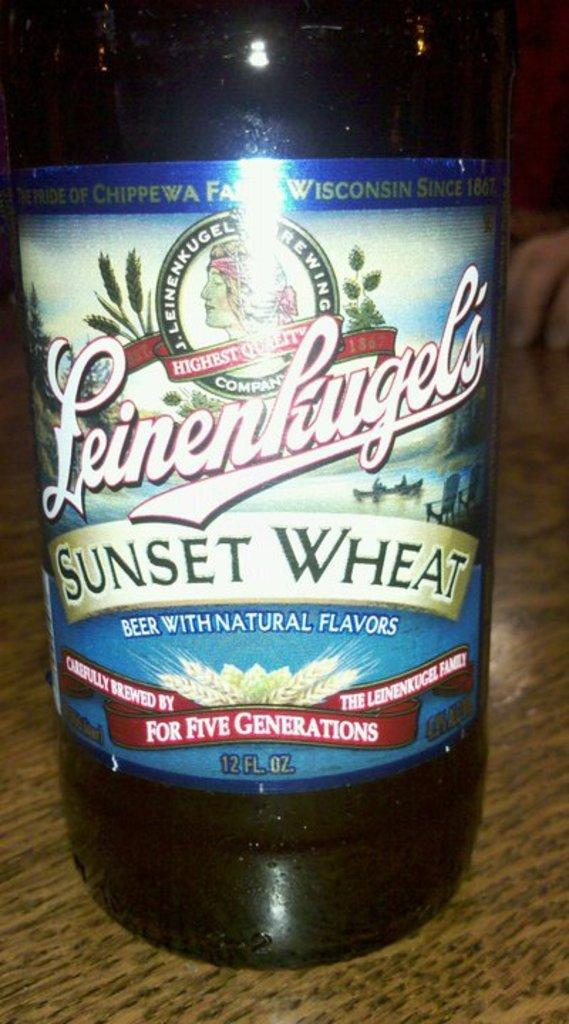<image>
Offer a succinct explanation of the picture presented. A bottle of SUNSET WHEAT beer is on a table. 